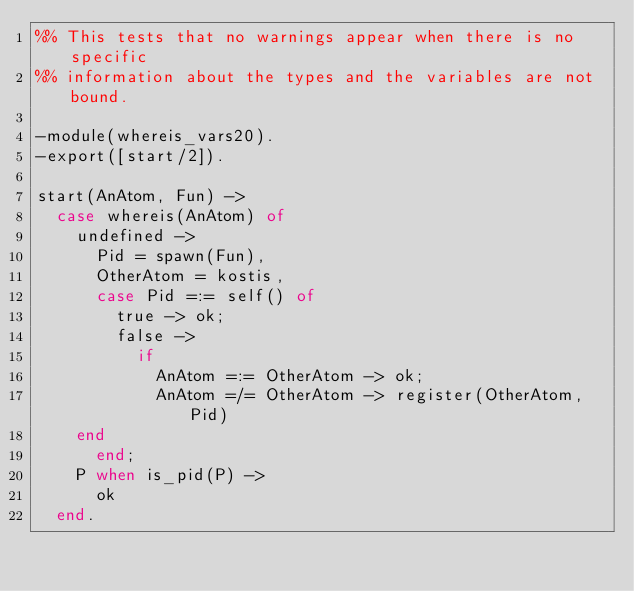<code> <loc_0><loc_0><loc_500><loc_500><_Erlang_>%% This tests that no warnings appear when there is no specific
%% information about the types and the variables are not bound.

-module(whereis_vars20).
-export([start/2]).

start(AnAtom, Fun) ->
  case whereis(AnAtom) of
    undefined ->
      Pid = spawn(Fun),
      OtherAtom = kostis,
      case Pid =:= self() of
        true -> ok;
        false ->
          if
            AnAtom =:= OtherAtom -> ok;
            AnAtom =/= OtherAtom -> register(OtherAtom, Pid)
	  end
      end;
    P when is_pid(P) ->
      ok
  end.
</code> 